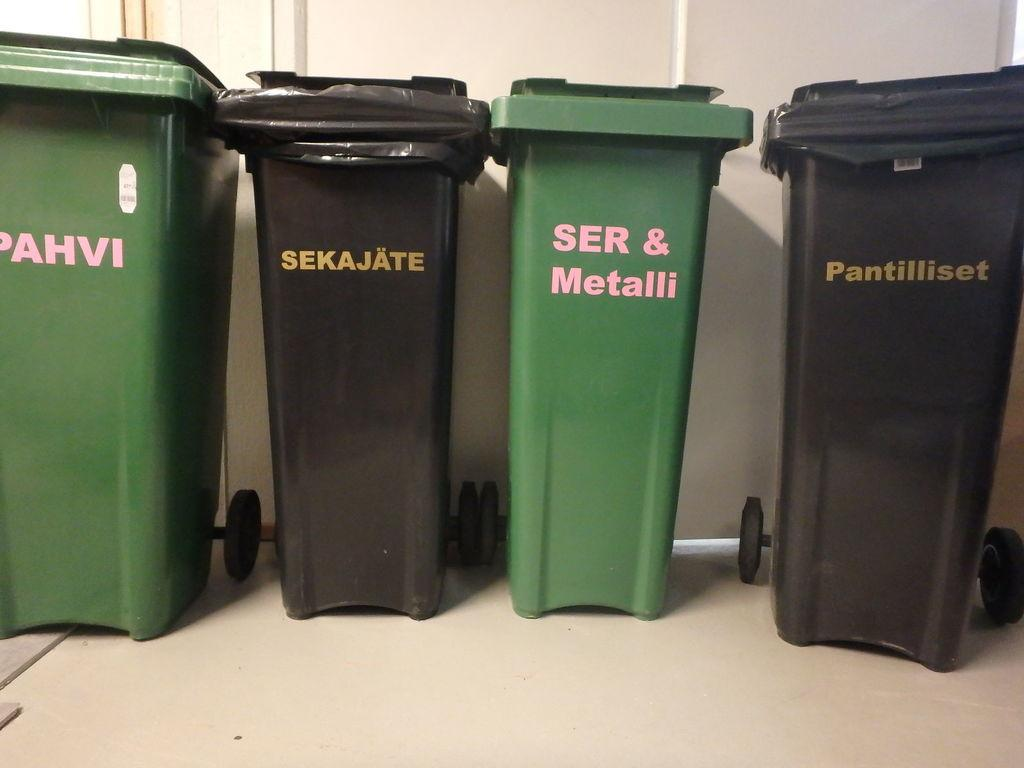<image>
Relay a brief, clear account of the picture shown. Several trash bins are here and one says "SER & Metalli." 